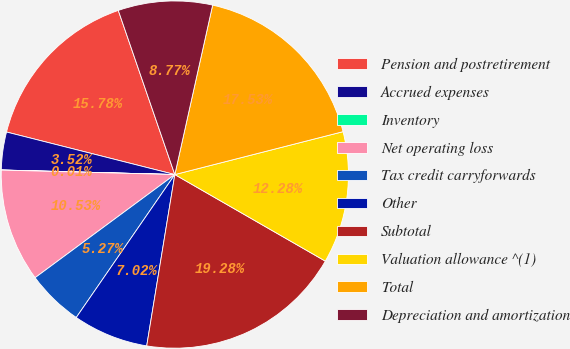Convert chart. <chart><loc_0><loc_0><loc_500><loc_500><pie_chart><fcel>Pension and postretirement<fcel>Accrued expenses<fcel>Inventory<fcel>Net operating loss<fcel>Tax credit carryforwards<fcel>Other<fcel>Subtotal<fcel>Valuation allowance ^(1)<fcel>Total<fcel>Depreciation and amortization<nl><fcel>15.78%<fcel>3.52%<fcel>0.01%<fcel>10.53%<fcel>5.27%<fcel>7.02%<fcel>19.28%<fcel>12.28%<fcel>17.53%<fcel>8.77%<nl></chart> 